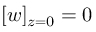Convert formula to latex. <formula><loc_0><loc_0><loc_500><loc_500>[ w ] _ { z = 0 } = 0</formula> 